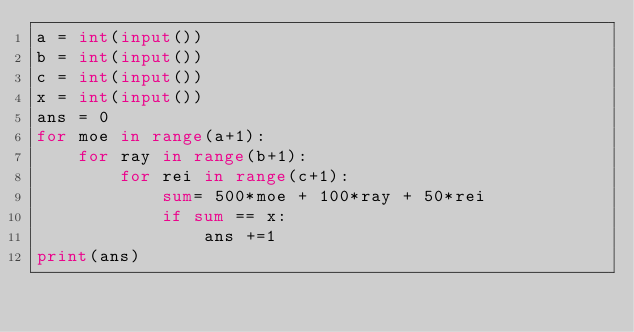Convert code to text. <code><loc_0><loc_0><loc_500><loc_500><_Python_>a = int(input())
b = int(input())
c = int(input())
x = int(input())
ans = 0
for moe in range(a+1):
    for ray in range(b+1):
        for rei in range(c+1):
            sum= 500*moe + 100*ray + 50*rei
            if sum == x:
                ans +=1
print(ans)</code> 